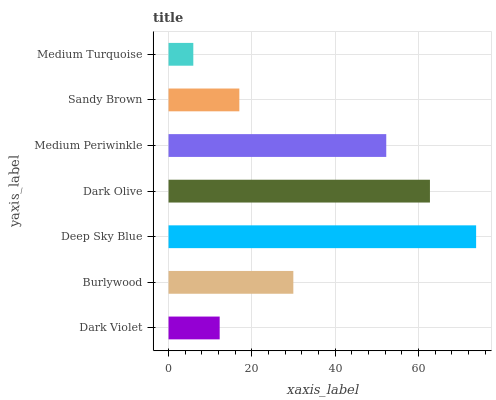Is Medium Turquoise the minimum?
Answer yes or no. Yes. Is Deep Sky Blue the maximum?
Answer yes or no. Yes. Is Burlywood the minimum?
Answer yes or no. No. Is Burlywood the maximum?
Answer yes or no. No. Is Burlywood greater than Dark Violet?
Answer yes or no. Yes. Is Dark Violet less than Burlywood?
Answer yes or no. Yes. Is Dark Violet greater than Burlywood?
Answer yes or no. No. Is Burlywood less than Dark Violet?
Answer yes or no. No. Is Burlywood the high median?
Answer yes or no. Yes. Is Burlywood the low median?
Answer yes or no. Yes. Is Sandy Brown the high median?
Answer yes or no. No. Is Deep Sky Blue the low median?
Answer yes or no. No. 